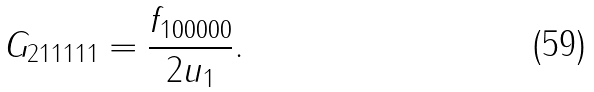<formula> <loc_0><loc_0><loc_500><loc_500>G _ { 2 1 1 1 1 1 } = \frac { f _ { 1 0 0 0 0 0 } } { 2 u _ { 1 } } .</formula> 